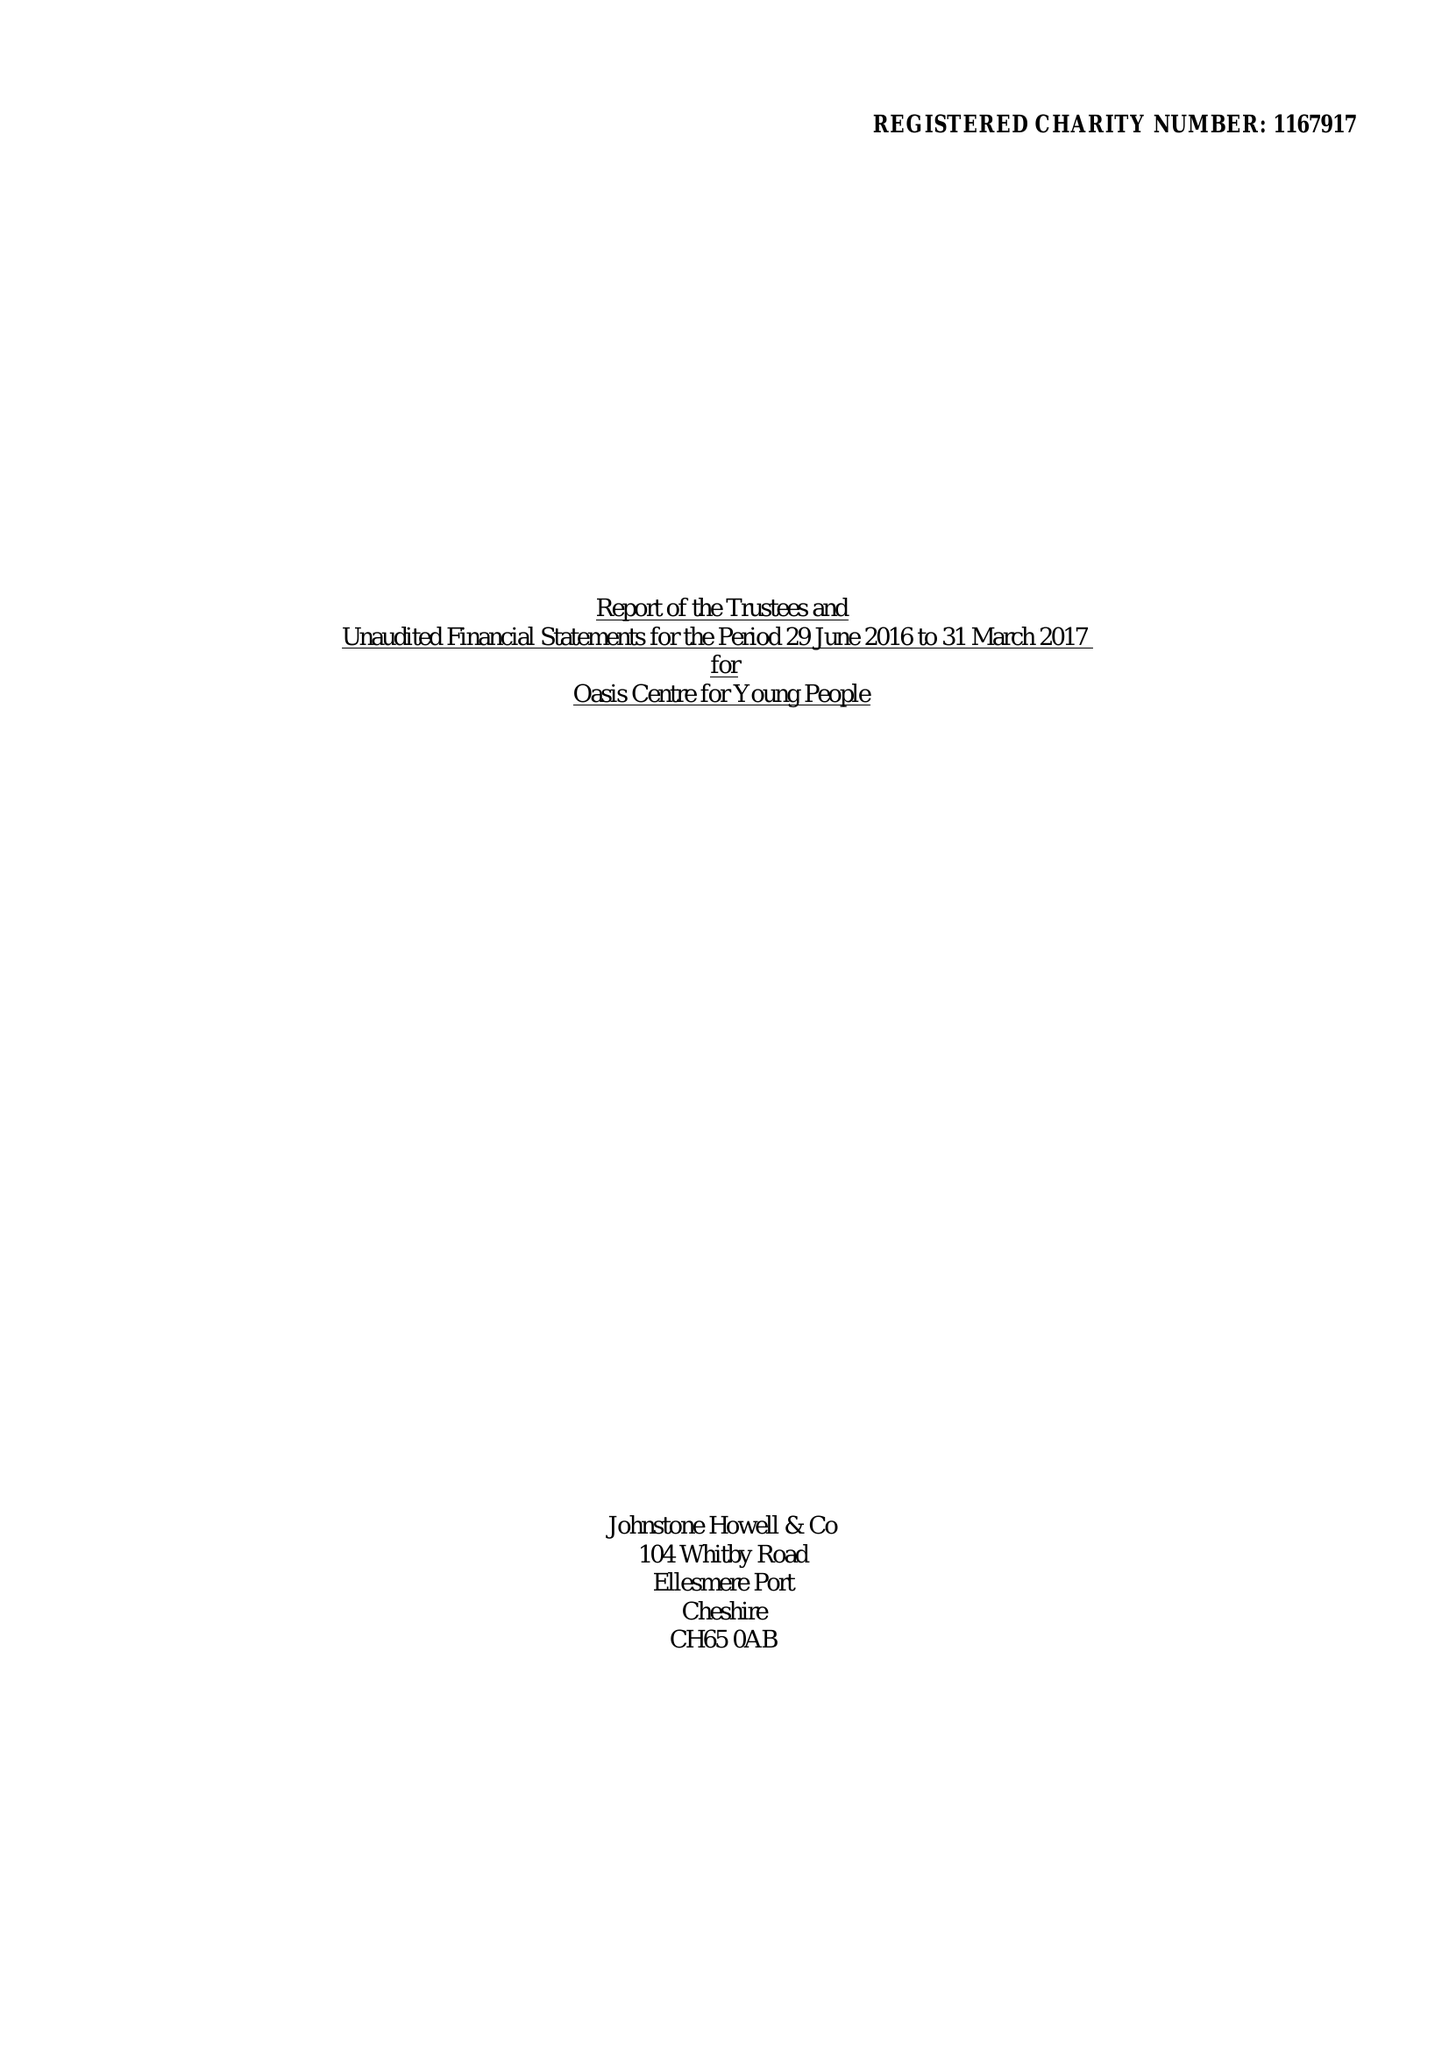What is the value for the address__street_line?
Answer the question using a single word or phrase. 63 OLIVER LANE 